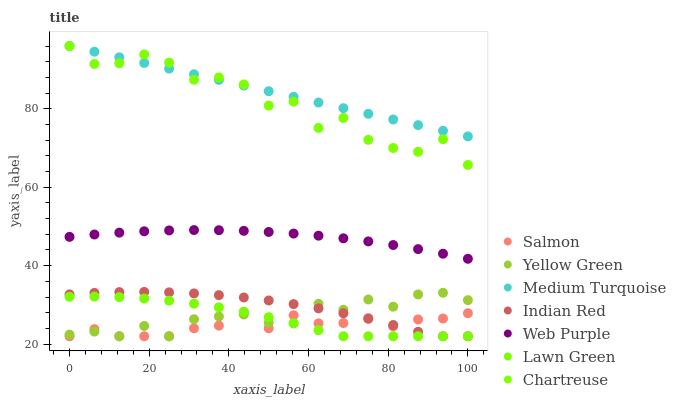Does Salmon have the minimum area under the curve?
Answer yes or no. Yes. Does Medium Turquoise have the maximum area under the curve?
Answer yes or no. Yes. Does Yellow Green have the minimum area under the curve?
Answer yes or no. No. Does Yellow Green have the maximum area under the curve?
Answer yes or no. No. Is Medium Turquoise the smoothest?
Answer yes or no. Yes. Is Chartreuse the roughest?
Answer yes or no. Yes. Is Yellow Green the smoothest?
Answer yes or no. No. Is Yellow Green the roughest?
Answer yes or no. No. Does Lawn Green have the lowest value?
Answer yes or no. Yes. Does Medium Turquoise have the lowest value?
Answer yes or no. No. Does Chartreuse have the highest value?
Answer yes or no. Yes. Does Yellow Green have the highest value?
Answer yes or no. No. Is Salmon less than Chartreuse?
Answer yes or no. Yes. Is Medium Turquoise greater than Salmon?
Answer yes or no. Yes. Does Indian Red intersect Lawn Green?
Answer yes or no. Yes. Is Indian Red less than Lawn Green?
Answer yes or no. No. Is Indian Red greater than Lawn Green?
Answer yes or no. No. Does Salmon intersect Chartreuse?
Answer yes or no. No. 